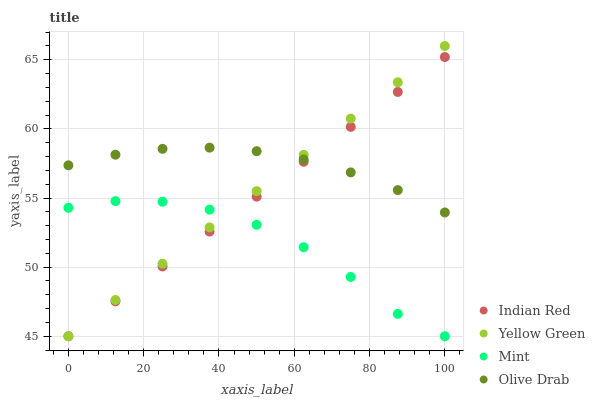Does Mint have the minimum area under the curve?
Answer yes or no. Yes. Does Olive Drab have the maximum area under the curve?
Answer yes or no. Yes. Does Yellow Green have the minimum area under the curve?
Answer yes or no. No. Does Yellow Green have the maximum area under the curve?
Answer yes or no. No. Is Yellow Green the smoothest?
Answer yes or no. Yes. Is Mint the roughest?
Answer yes or no. Yes. Is Mint the smoothest?
Answer yes or no. No. Is Yellow Green the roughest?
Answer yes or no. No. Does Mint have the lowest value?
Answer yes or no. Yes. Does Yellow Green have the highest value?
Answer yes or no. Yes. Does Mint have the highest value?
Answer yes or no. No. Is Mint less than Olive Drab?
Answer yes or no. Yes. Is Olive Drab greater than Mint?
Answer yes or no. Yes. Does Olive Drab intersect Indian Red?
Answer yes or no. Yes. Is Olive Drab less than Indian Red?
Answer yes or no. No. Is Olive Drab greater than Indian Red?
Answer yes or no. No. Does Mint intersect Olive Drab?
Answer yes or no. No. 